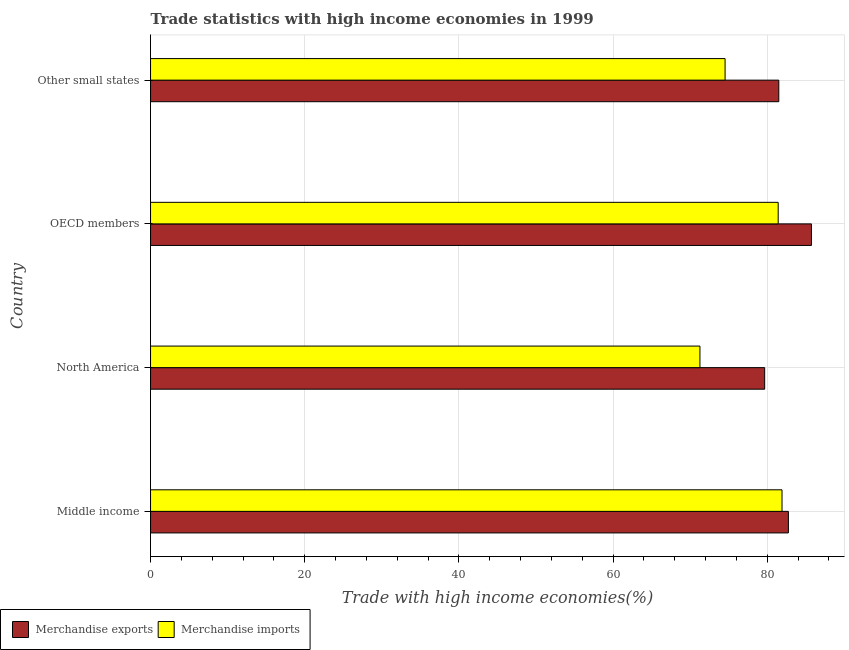How many groups of bars are there?
Offer a very short reply. 4. Are the number of bars on each tick of the Y-axis equal?
Ensure brevity in your answer.  Yes. How many bars are there on the 2nd tick from the bottom?
Offer a terse response. 2. What is the label of the 4th group of bars from the top?
Offer a very short reply. Middle income. What is the merchandise imports in Other small states?
Your response must be concise. 74.53. Across all countries, what is the maximum merchandise exports?
Provide a short and direct response. 85.73. Across all countries, what is the minimum merchandise imports?
Your answer should be compact. 71.27. In which country was the merchandise exports maximum?
Give a very brief answer. OECD members. What is the total merchandise imports in the graph?
Keep it short and to the point. 309.13. What is the difference between the merchandise exports in Middle income and that in North America?
Ensure brevity in your answer.  3.08. What is the difference between the merchandise exports in North America and the merchandise imports in Other small states?
Your answer should be compact. 5.14. What is the average merchandise exports per country?
Ensure brevity in your answer.  82.41. What is the difference between the merchandise exports and merchandise imports in OECD members?
Ensure brevity in your answer.  4.32. What is the ratio of the merchandise exports in North America to that in Other small states?
Your answer should be very brief. 0.98. Is the merchandise imports in Middle income less than that in OECD members?
Give a very brief answer. No. What is the difference between the highest and the second highest merchandise exports?
Provide a short and direct response. 2.99. What is the difference between the highest and the lowest merchandise exports?
Ensure brevity in your answer.  6.07. In how many countries, is the merchandise exports greater than the average merchandise exports taken over all countries?
Make the answer very short. 2. What does the 1st bar from the top in Middle income represents?
Offer a terse response. Merchandise imports. What does the 1st bar from the bottom in Middle income represents?
Your answer should be very brief. Merchandise exports. How many bars are there?
Ensure brevity in your answer.  8. Are all the bars in the graph horizontal?
Offer a very short reply. Yes. How many countries are there in the graph?
Your answer should be compact. 4. What is the difference between two consecutive major ticks on the X-axis?
Offer a terse response. 20. Are the values on the major ticks of X-axis written in scientific E-notation?
Your answer should be compact. No. Does the graph contain any zero values?
Your answer should be very brief. No. Where does the legend appear in the graph?
Provide a succinct answer. Bottom left. How many legend labels are there?
Your response must be concise. 2. How are the legend labels stacked?
Your answer should be very brief. Horizontal. What is the title of the graph?
Offer a very short reply. Trade statistics with high income economies in 1999. What is the label or title of the X-axis?
Your response must be concise. Trade with high income economies(%). What is the label or title of the Y-axis?
Your answer should be compact. Country. What is the Trade with high income economies(%) of Merchandise exports in Middle income?
Offer a terse response. 82.74. What is the Trade with high income economies(%) of Merchandise imports in Middle income?
Ensure brevity in your answer.  81.91. What is the Trade with high income economies(%) of Merchandise exports in North America?
Ensure brevity in your answer.  79.66. What is the Trade with high income economies(%) of Merchandise imports in North America?
Make the answer very short. 71.27. What is the Trade with high income economies(%) in Merchandise exports in OECD members?
Keep it short and to the point. 85.73. What is the Trade with high income economies(%) in Merchandise imports in OECD members?
Your response must be concise. 81.42. What is the Trade with high income economies(%) in Merchandise exports in Other small states?
Ensure brevity in your answer.  81.5. What is the Trade with high income economies(%) of Merchandise imports in Other small states?
Make the answer very short. 74.53. Across all countries, what is the maximum Trade with high income economies(%) in Merchandise exports?
Your response must be concise. 85.73. Across all countries, what is the maximum Trade with high income economies(%) of Merchandise imports?
Give a very brief answer. 81.91. Across all countries, what is the minimum Trade with high income economies(%) in Merchandise exports?
Make the answer very short. 79.66. Across all countries, what is the minimum Trade with high income economies(%) in Merchandise imports?
Offer a very short reply. 71.27. What is the total Trade with high income economies(%) in Merchandise exports in the graph?
Your answer should be compact. 329.63. What is the total Trade with high income economies(%) of Merchandise imports in the graph?
Your answer should be compact. 309.13. What is the difference between the Trade with high income economies(%) in Merchandise exports in Middle income and that in North America?
Your answer should be compact. 3.08. What is the difference between the Trade with high income economies(%) of Merchandise imports in Middle income and that in North America?
Offer a terse response. 10.65. What is the difference between the Trade with high income economies(%) in Merchandise exports in Middle income and that in OECD members?
Your answer should be compact. -2.99. What is the difference between the Trade with high income economies(%) in Merchandise imports in Middle income and that in OECD members?
Offer a very short reply. 0.5. What is the difference between the Trade with high income economies(%) of Merchandise exports in Middle income and that in Other small states?
Your answer should be very brief. 1.24. What is the difference between the Trade with high income economies(%) of Merchandise imports in Middle income and that in Other small states?
Your response must be concise. 7.39. What is the difference between the Trade with high income economies(%) of Merchandise exports in North America and that in OECD members?
Make the answer very short. -6.07. What is the difference between the Trade with high income economies(%) in Merchandise imports in North America and that in OECD members?
Ensure brevity in your answer.  -10.15. What is the difference between the Trade with high income economies(%) of Merchandise exports in North America and that in Other small states?
Your answer should be very brief. -1.83. What is the difference between the Trade with high income economies(%) in Merchandise imports in North America and that in Other small states?
Make the answer very short. -3.26. What is the difference between the Trade with high income economies(%) of Merchandise exports in OECD members and that in Other small states?
Make the answer very short. 4.23. What is the difference between the Trade with high income economies(%) of Merchandise imports in OECD members and that in Other small states?
Provide a short and direct response. 6.89. What is the difference between the Trade with high income economies(%) in Merchandise exports in Middle income and the Trade with high income economies(%) in Merchandise imports in North America?
Your answer should be very brief. 11.47. What is the difference between the Trade with high income economies(%) in Merchandise exports in Middle income and the Trade with high income economies(%) in Merchandise imports in OECD members?
Give a very brief answer. 1.32. What is the difference between the Trade with high income economies(%) of Merchandise exports in Middle income and the Trade with high income economies(%) of Merchandise imports in Other small states?
Make the answer very short. 8.21. What is the difference between the Trade with high income economies(%) in Merchandise exports in North America and the Trade with high income economies(%) in Merchandise imports in OECD members?
Provide a short and direct response. -1.75. What is the difference between the Trade with high income economies(%) in Merchandise exports in North America and the Trade with high income economies(%) in Merchandise imports in Other small states?
Ensure brevity in your answer.  5.14. What is the difference between the Trade with high income economies(%) in Merchandise exports in OECD members and the Trade with high income economies(%) in Merchandise imports in Other small states?
Offer a very short reply. 11.2. What is the average Trade with high income economies(%) in Merchandise exports per country?
Ensure brevity in your answer.  82.41. What is the average Trade with high income economies(%) of Merchandise imports per country?
Keep it short and to the point. 77.28. What is the difference between the Trade with high income economies(%) in Merchandise exports and Trade with high income economies(%) in Merchandise imports in Middle income?
Provide a succinct answer. 0.83. What is the difference between the Trade with high income economies(%) in Merchandise exports and Trade with high income economies(%) in Merchandise imports in North America?
Give a very brief answer. 8.4. What is the difference between the Trade with high income economies(%) in Merchandise exports and Trade with high income economies(%) in Merchandise imports in OECD members?
Provide a succinct answer. 4.31. What is the difference between the Trade with high income economies(%) of Merchandise exports and Trade with high income economies(%) of Merchandise imports in Other small states?
Your response must be concise. 6.97. What is the ratio of the Trade with high income economies(%) in Merchandise exports in Middle income to that in North America?
Ensure brevity in your answer.  1.04. What is the ratio of the Trade with high income economies(%) in Merchandise imports in Middle income to that in North America?
Make the answer very short. 1.15. What is the ratio of the Trade with high income economies(%) in Merchandise exports in Middle income to that in OECD members?
Ensure brevity in your answer.  0.97. What is the ratio of the Trade with high income economies(%) of Merchandise imports in Middle income to that in OECD members?
Your answer should be very brief. 1.01. What is the ratio of the Trade with high income economies(%) in Merchandise exports in Middle income to that in Other small states?
Your response must be concise. 1.02. What is the ratio of the Trade with high income economies(%) in Merchandise imports in Middle income to that in Other small states?
Your answer should be compact. 1.1. What is the ratio of the Trade with high income economies(%) in Merchandise exports in North America to that in OECD members?
Make the answer very short. 0.93. What is the ratio of the Trade with high income economies(%) in Merchandise imports in North America to that in OECD members?
Offer a terse response. 0.88. What is the ratio of the Trade with high income economies(%) of Merchandise exports in North America to that in Other small states?
Make the answer very short. 0.98. What is the ratio of the Trade with high income economies(%) of Merchandise imports in North America to that in Other small states?
Your answer should be compact. 0.96. What is the ratio of the Trade with high income economies(%) in Merchandise exports in OECD members to that in Other small states?
Your answer should be very brief. 1.05. What is the ratio of the Trade with high income economies(%) of Merchandise imports in OECD members to that in Other small states?
Your answer should be compact. 1.09. What is the difference between the highest and the second highest Trade with high income economies(%) of Merchandise exports?
Offer a terse response. 2.99. What is the difference between the highest and the second highest Trade with high income economies(%) in Merchandise imports?
Provide a short and direct response. 0.5. What is the difference between the highest and the lowest Trade with high income economies(%) of Merchandise exports?
Provide a succinct answer. 6.07. What is the difference between the highest and the lowest Trade with high income economies(%) of Merchandise imports?
Ensure brevity in your answer.  10.65. 